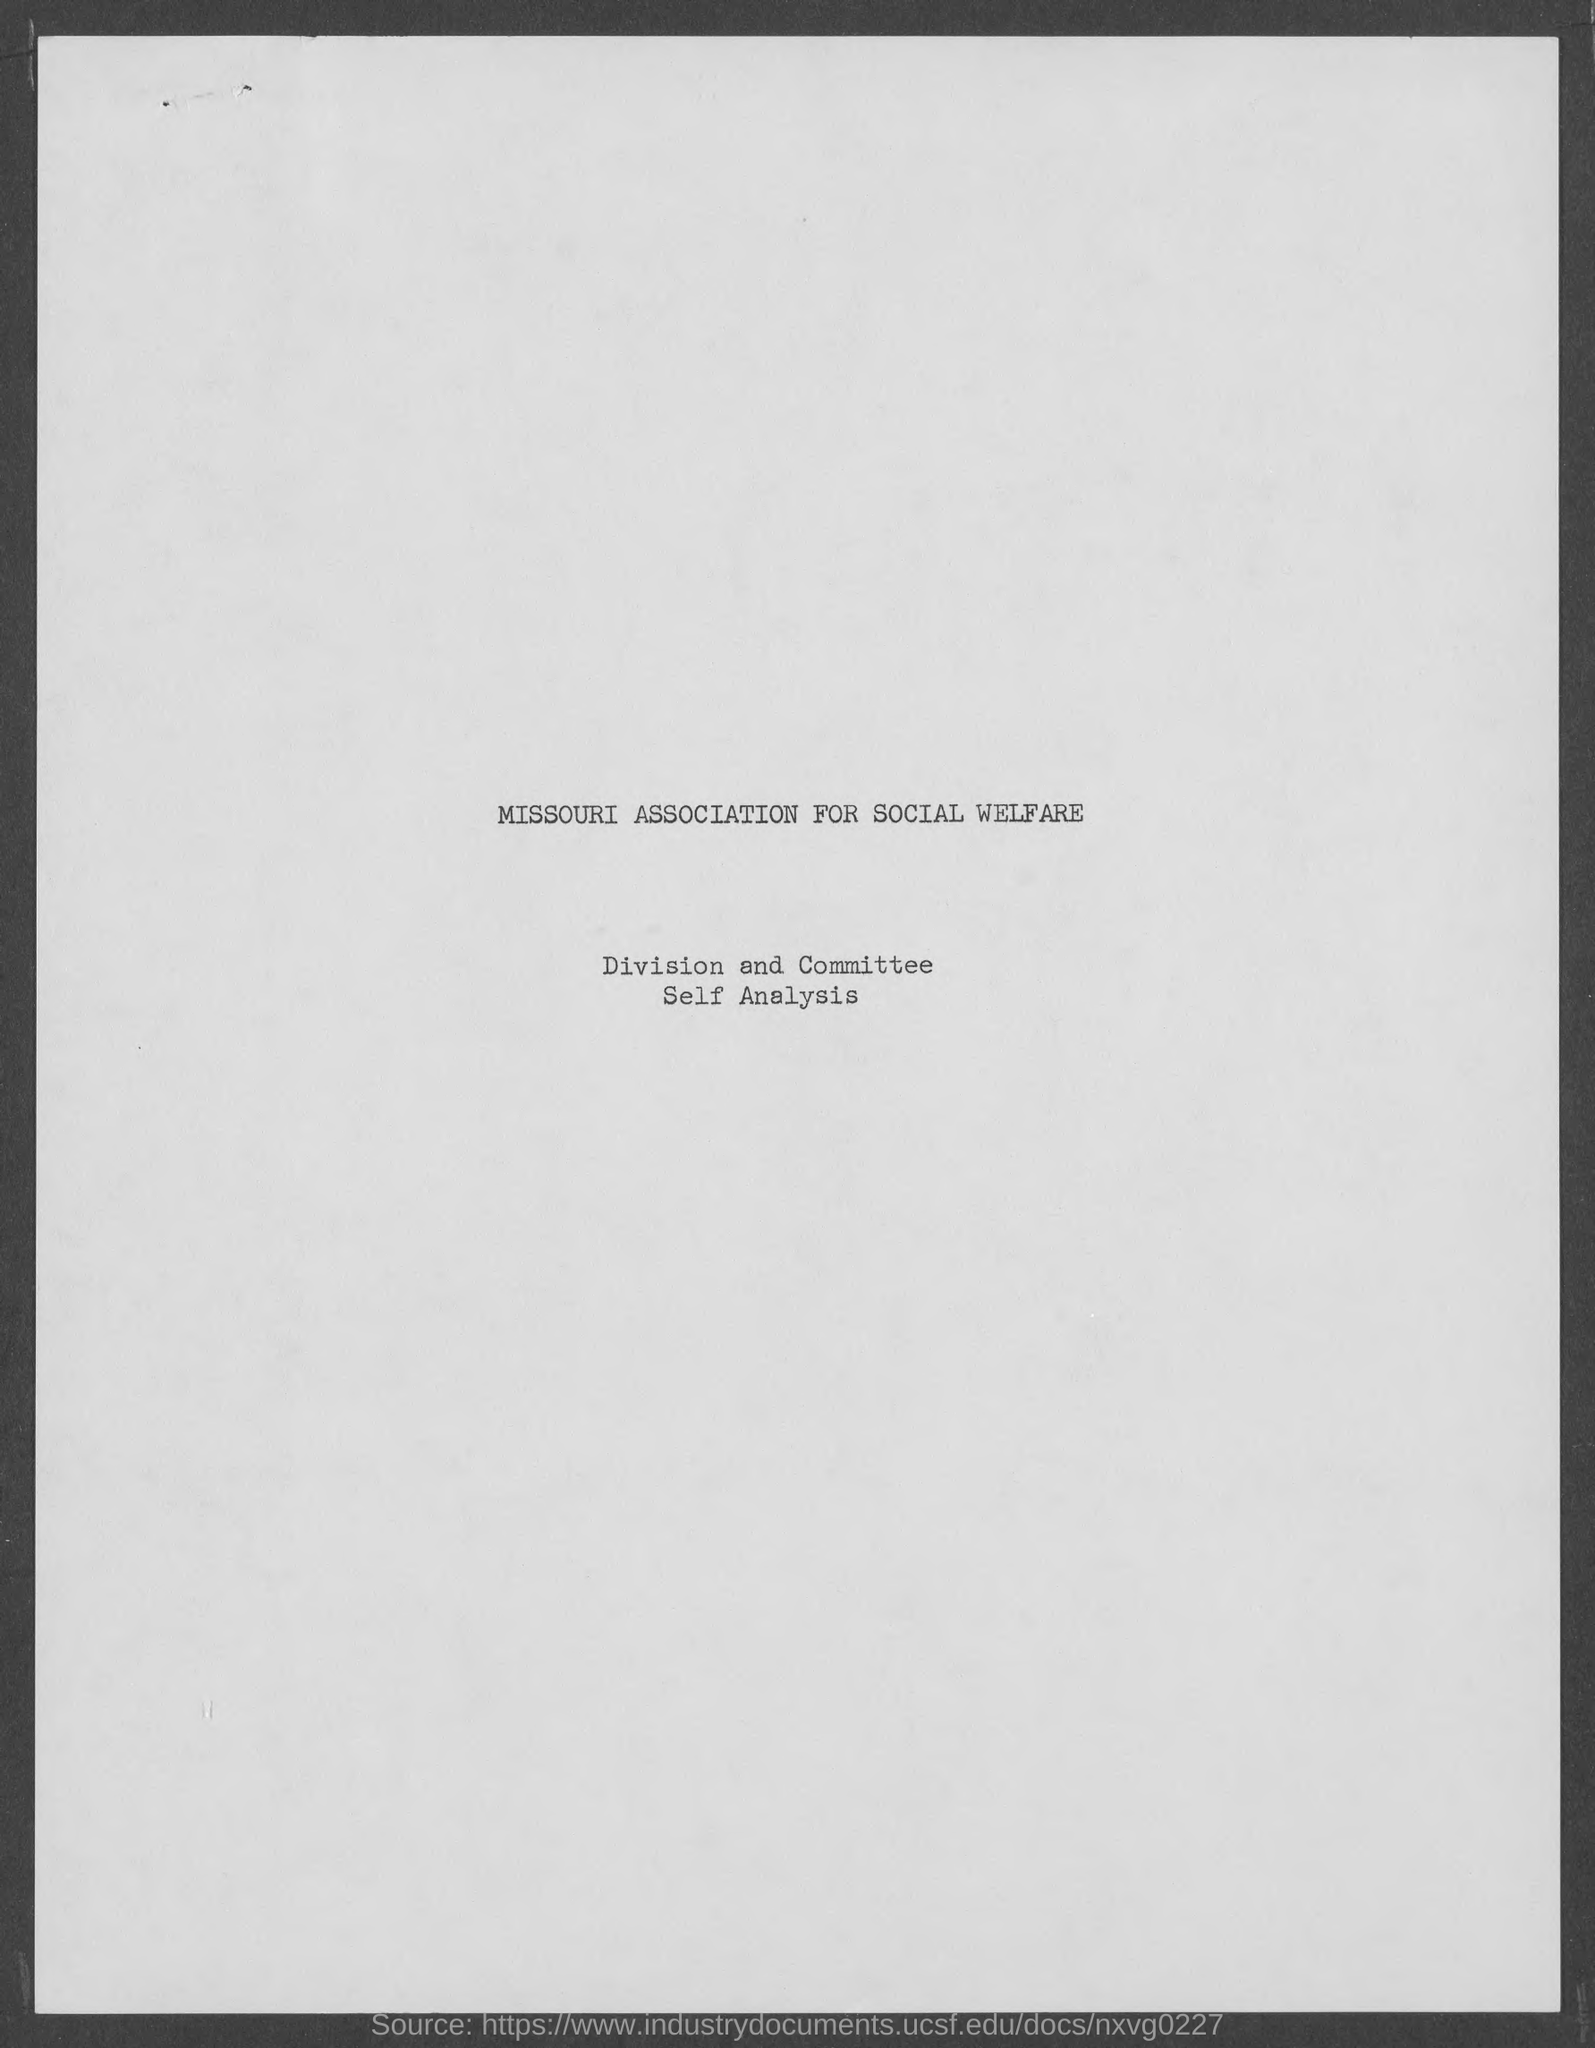Which association is mentioned in the document?
Provide a succinct answer. Missouri Association for social welfare. 